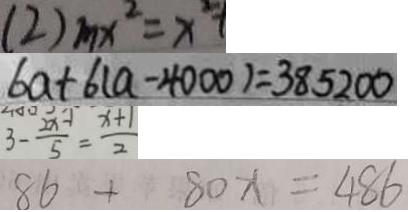Convert formula to latex. <formula><loc_0><loc_0><loc_500><loc_500>( 2 ) m x ^ { 2 } = x ^ { 2 } + 
 6 a + 6 ( a - 4 0 0 0 ) = 3 8 5 2 0 0 
 3 - \frac { 2 x - 1 } { 5 } = \frac { x + 1 } { 2 } 
 8 6 + 8 0 x = 4 8 6</formula> 